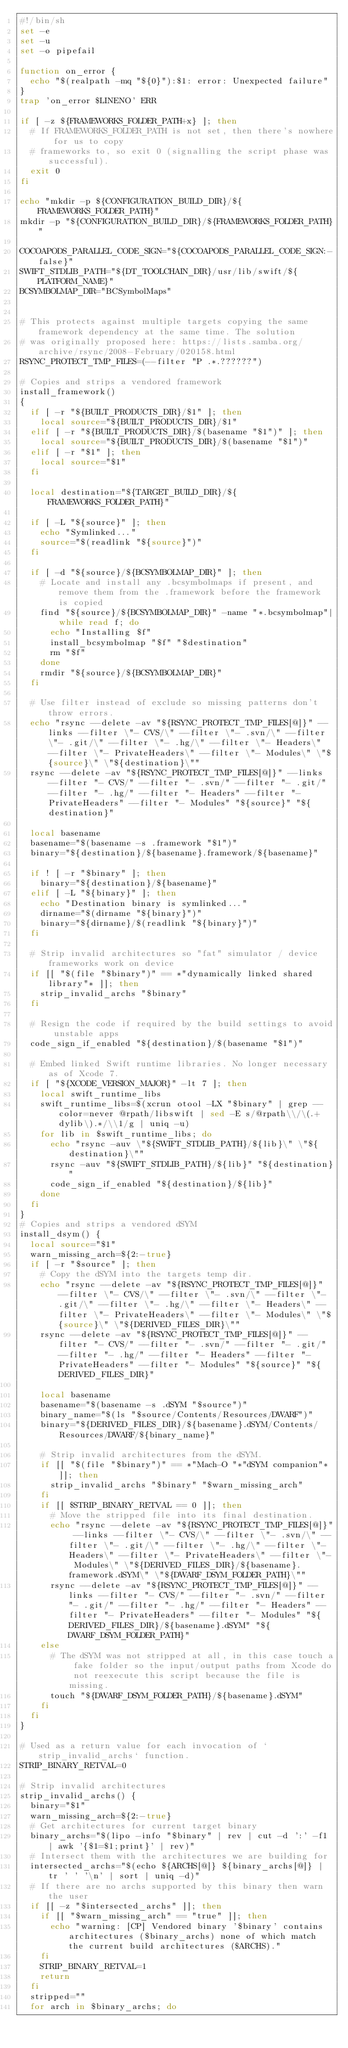Convert code to text. <code><loc_0><loc_0><loc_500><loc_500><_Bash_>#!/bin/sh
set -e
set -u
set -o pipefail

function on_error {
  echo "$(realpath -mq "${0}"):$1: error: Unexpected failure"
}
trap 'on_error $LINENO' ERR

if [ -z ${FRAMEWORKS_FOLDER_PATH+x} ]; then
  # If FRAMEWORKS_FOLDER_PATH is not set, then there's nowhere for us to copy
  # frameworks to, so exit 0 (signalling the script phase was successful).
  exit 0
fi

echo "mkdir -p ${CONFIGURATION_BUILD_DIR}/${FRAMEWORKS_FOLDER_PATH}"
mkdir -p "${CONFIGURATION_BUILD_DIR}/${FRAMEWORKS_FOLDER_PATH}"

COCOAPODS_PARALLEL_CODE_SIGN="${COCOAPODS_PARALLEL_CODE_SIGN:-false}"
SWIFT_STDLIB_PATH="${DT_TOOLCHAIN_DIR}/usr/lib/swift/${PLATFORM_NAME}"
BCSYMBOLMAP_DIR="BCSymbolMaps"


# This protects against multiple targets copying the same framework dependency at the same time. The solution
# was originally proposed here: https://lists.samba.org/archive/rsync/2008-February/020158.html
RSYNC_PROTECT_TMP_FILES=(--filter "P .*.??????")

# Copies and strips a vendored framework
install_framework()
{
  if [ -r "${BUILT_PRODUCTS_DIR}/$1" ]; then
    local source="${BUILT_PRODUCTS_DIR}/$1"
  elif [ -r "${BUILT_PRODUCTS_DIR}/$(basename "$1")" ]; then
    local source="${BUILT_PRODUCTS_DIR}/$(basename "$1")"
  elif [ -r "$1" ]; then
    local source="$1"
  fi

  local destination="${TARGET_BUILD_DIR}/${FRAMEWORKS_FOLDER_PATH}"

  if [ -L "${source}" ]; then
    echo "Symlinked..."
    source="$(readlink "${source}")"
  fi

  if [ -d "${source}/${BCSYMBOLMAP_DIR}" ]; then
    # Locate and install any .bcsymbolmaps if present, and remove them from the .framework before the framework is copied
    find "${source}/${BCSYMBOLMAP_DIR}" -name "*.bcsymbolmap"|while read f; do
      echo "Installing $f"
      install_bcsymbolmap "$f" "$destination"
      rm "$f"
    done
    rmdir "${source}/${BCSYMBOLMAP_DIR}"
  fi

  # Use filter instead of exclude so missing patterns don't throw errors.
  echo "rsync --delete -av "${RSYNC_PROTECT_TMP_FILES[@]}" --links --filter \"- CVS/\" --filter \"- .svn/\" --filter \"- .git/\" --filter \"- .hg/\" --filter \"- Headers\" --filter \"- PrivateHeaders\" --filter \"- Modules\" \"${source}\" \"${destination}\""
  rsync --delete -av "${RSYNC_PROTECT_TMP_FILES[@]}" --links --filter "- CVS/" --filter "- .svn/" --filter "- .git/" --filter "- .hg/" --filter "- Headers" --filter "- PrivateHeaders" --filter "- Modules" "${source}" "${destination}"

  local basename
  basename="$(basename -s .framework "$1")"
  binary="${destination}/${basename}.framework/${basename}"

  if ! [ -r "$binary" ]; then
    binary="${destination}/${basename}"
  elif [ -L "${binary}" ]; then
    echo "Destination binary is symlinked..."
    dirname="$(dirname "${binary}")"
    binary="${dirname}/$(readlink "${binary}")"
  fi

  # Strip invalid architectures so "fat" simulator / device frameworks work on device
  if [[ "$(file "$binary")" == *"dynamically linked shared library"* ]]; then
    strip_invalid_archs "$binary"
  fi

  # Resign the code if required by the build settings to avoid unstable apps
  code_sign_if_enabled "${destination}/$(basename "$1")"

  # Embed linked Swift runtime libraries. No longer necessary as of Xcode 7.
  if [ "${XCODE_VERSION_MAJOR}" -lt 7 ]; then
    local swift_runtime_libs
    swift_runtime_libs=$(xcrun otool -LX "$binary" | grep --color=never @rpath/libswift | sed -E s/@rpath\\/\(.+dylib\).*/\\1/g | uniq -u)
    for lib in $swift_runtime_libs; do
      echo "rsync -auv \"${SWIFT_STDLIB_PATH}/${lib}\" \"${destination}\""
      rsync -auv "${SWIFT_STDLIB_PATH}/${lib}" "${destination}"
      code_sign_if_enabled "${destination}/${lib}"
    done
  fi
}
# Copies and strips a vendored dSYM
install_dsym() {
  local source="$1"
  warn_missing_arch=${2:-true}
  if [ -r "$source" ]; then
    # Copy the dSYM into the targets temp dir.
    echo "rsync --delete -av "${RSYNC_PROTECT_TMP_FILES[@]}" --filter \"- CVS/\" --filter \"- .svn/\" --filter \"- .git/\" --filter \"- .hg/\" --filter \"- Headers\" --filter \"- PrivateHeaders\" --filter \"- Modules\" \"${source}\" \"${DERIVED_FILES_DIR}\""
    rsync --delete -av "${RSYNC_PROTECT_TMP_FILES[@]}" --filter "- CVS/" --filter "- .svn/" --filter "- .git/" --filter "- .hg/" --filter "- Headers" --filter "- PrivateHeaders" --filter "- Modules" "${source}" "${DERIVED_FILES_DIR}"

    local basename
    basename="$(basename -s .dSYM "$source")"
    binary_name="$(ls "$source/Contents/Resources/DWARF")"
    binary="${DERIVED_FILES_DIR}/${basename}.dSYM/Contents/Resources/DWARF/${binary_name}"

    # Strip invalid architectures from the dSYM.
    if [[ "$(file "$binary")" == *"Mach-O "*"dSYM companion"* ]]; then
      strip_invalid_archs "$binary" "$warn_missing_arch"
    fi
    if [[ $STRIP_BINARY_RETVAL == 0 ]]; then
      # Move the stripped file into its final destination.
      echo "rsync --delete -av "${RSYNC_PROTECT_TMP_FILES[@]}" --links --filter \"- CVS/\" --filter \"- .svn/\" --filter \"- .git/\" --filter \"- .hg/\" --filter \"- Headers\" --filter \"- PrivateHeaders\" --filter \"- Modules\" \"${DERIVED_FILES_DIR}/${basename}.framework.dSYM\" \"${DWARF_DSYM_FOLDER_PATH}\""
      rsync --delete -av "${RSYNC_PROTECT_TMP_FILES[@]}" --links --filter "- CVS/" --filter "- .svn/" --filter "- .git/" --filter "- .hg/" --filter "- Headers" --filter "- PrivateHeaders" --filter "- Modules" "${DERIVED_FILES_DIR}/${basename}.dSYM" "${DWARF_DSYM_FOLDER_PATH}"
    else
      # The dSYM was not stripped at all, in this case touch a fake folder so the input/output paths from Xcode do not reexecute this script because the file is missing.
      touch "${DWARF_DSYM_FOLDER_PATH}/${basename}.dSYM"
    fi
  fi
}

# Used as a return value for each invocation of `strip_invalid_archs` function.
STRIP_BINARY_RETVAL=0

# Strip invalid architectures
strip_invalid_archs() {
  binary="$1"
  warn_missing_arch=${2:-true}
  # Get architectures for current target binary
  binary_archs="$(lipo -info "$binary" | rev | cut -d ':' -f1 | awk '{$1=$1;print}' | rev)"
  # Intersect them with the architectures we are building for
  intersected_archs="$(echo ${ARCHS[@]} ${binary_archs[@]} | tr ' ' '\n' | sort | uniq -d)"
  # If there are no archs supported by this binary then warn the user
  if [[ -z "$intersected_archs" ]]; then
    if [[ "$warn_missing_arch" == "true" ]]; then
      echo "warning: [CP] Vendored binary '$binary' contains architectures ($binary_archs) none of which match the current build architectures ($ARCHS)."
    fi
    STRIP_BINARY_RETVAL=1
    return
  fi
  stripped=""
  for arch in $binary_archs; do</code> 